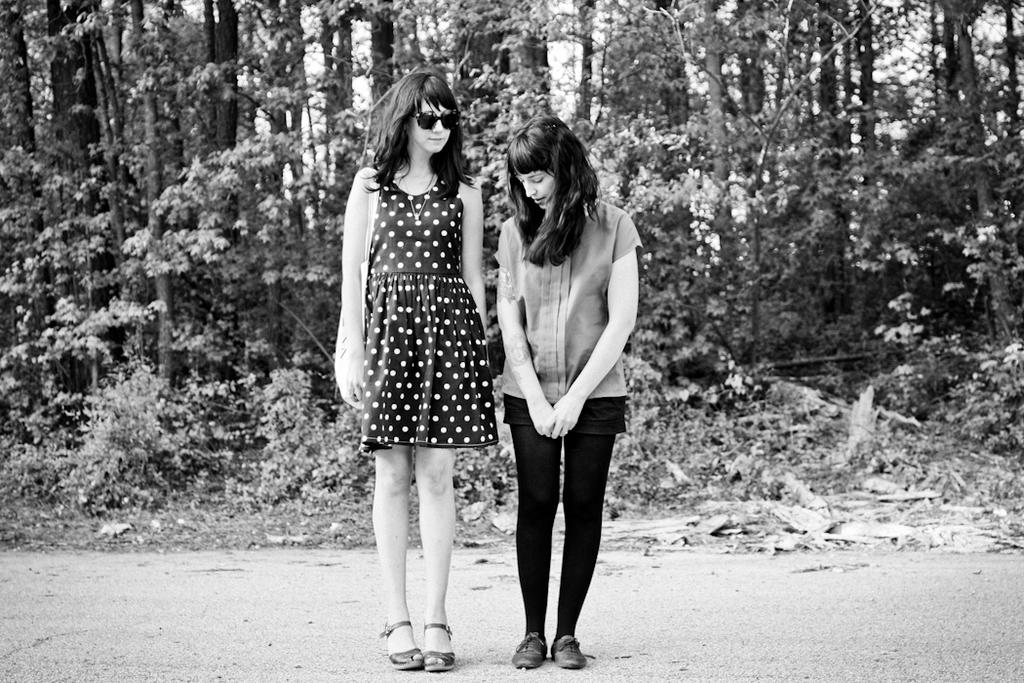What is the color scheme of the image? The image is black and white. What can be seen in the foreground of the image? There are two women standing on the road. What type of vegetation is visible in the background of the image? There are plants and trees in the background of the image. What type of glue is being used by the women in the image? There is no glue present in the image, and the women are not using any glue. What type of hill can be seen in the background of the image? There is no hill visible in the image; it features a road with two women and a background of plants and trees. 